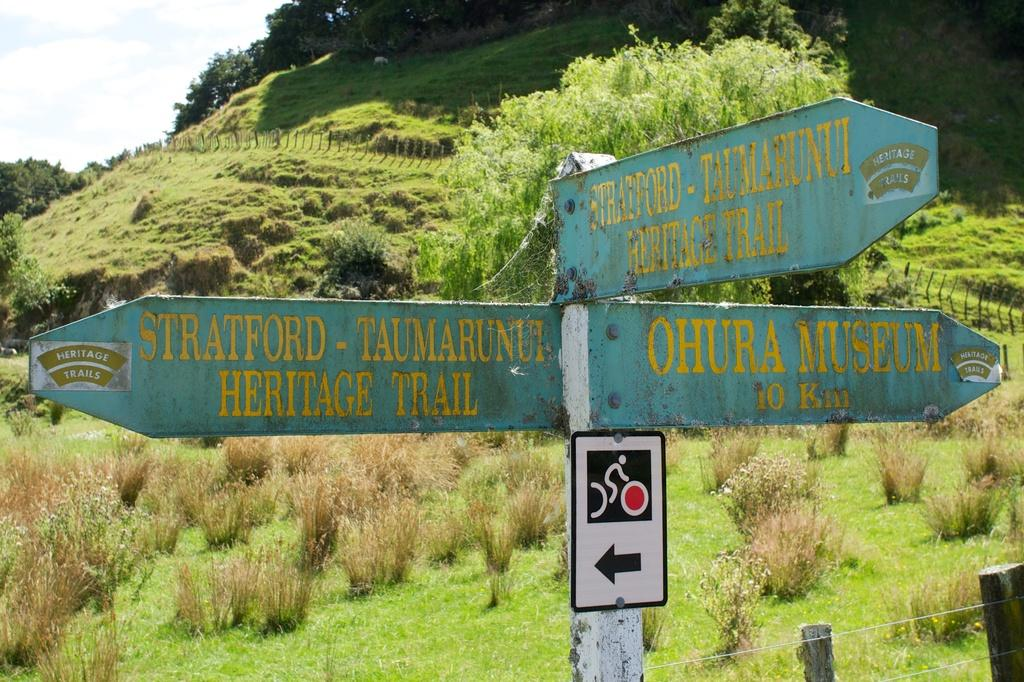<image>
Offer a succinct explanation of the picture presented. A signpost shows the way to Ohura Museum. 